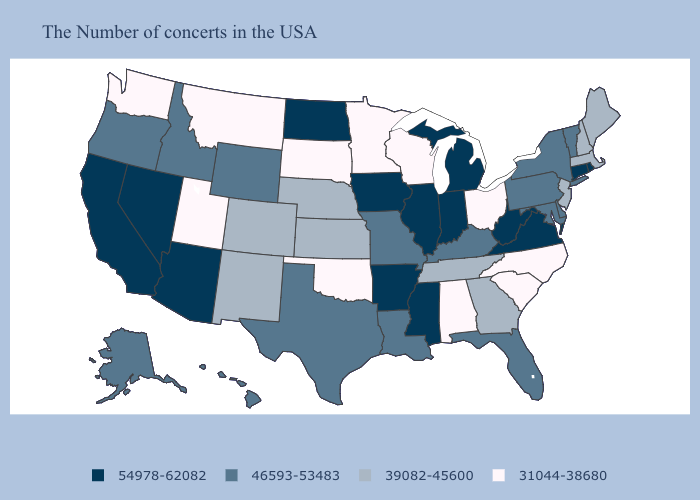Does Arkansas have a lower value than Oregon?
Be succinct. No. Does Kansas have the lowest value in the MidWest?
Be succinct. No. Name the states that have a value in the range 39082-45600?
Write a very short answer. Maine, Massachusetts, New Hampshire, New Jersey, Georgia, Tennessee, Kansas, Nebraska, Colorado, New Mexico. Does the first symbol in the legend represent the smallest category?
Concise answer only. No. Name the states that have a value in the range 39082-45600?
Keep it brief. Maine, Massachusetts, New Hampshire, New Jersey, Georgia, Tennessee, Kansas, Nebraska, Colorado, New Mexico. What is the highest value in the MidWest ?
Be succinct. 54978-62082. Name the states that have a value in the range 54978-62082?
Answer briefly. Rhode Island, Connecticut, Virginia, West Virginia, Michigan, Indiana, Illinois, Mississippi, Arkansas, Iowa, North Dakota, Arizona, Nevada, California. Does Michigan have a higher value than Indiana?
Quick response, please. No. Does North Carolina have the lowest value in the South?
Write a very short answer. Yes. Which states have the lowest value in the USA?
Short answer required. North Carolina, South Carolina, Ohio, Alabama, Wisconsin, Minnesota, Oklahoma, South Dakota, Utah, Montana, Washington. What is the highest value in states that border Texas?
Quick response, please. 54978-62082. Does Oregon have a lower value than Indiana?
Concise answer only. Yes. Among the states that border New Mexico , which have the highest value?
Be succinct. Arizona. 